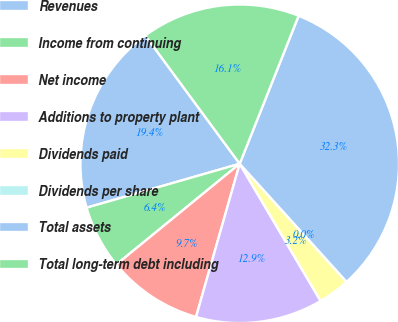Convert chart. <chart><loc_0><loc_0><loc_500><loc_500><pie_chart><fcel>Revenues<fcel>Income from continuing<fcel>Net income<fcel>Additions to property plant<fcel>Dividends paid<fcel>Dividends per share<fcel>Total assets<fcel>Total long-term debt including<nl><fcel>19.35%<fcel>6.45%<fcel>9.68%<fcel>12.9%<fcel>3.23%<fcel>0.0%<fcel>32.26%<fcel>16.13%<nl></chart> 